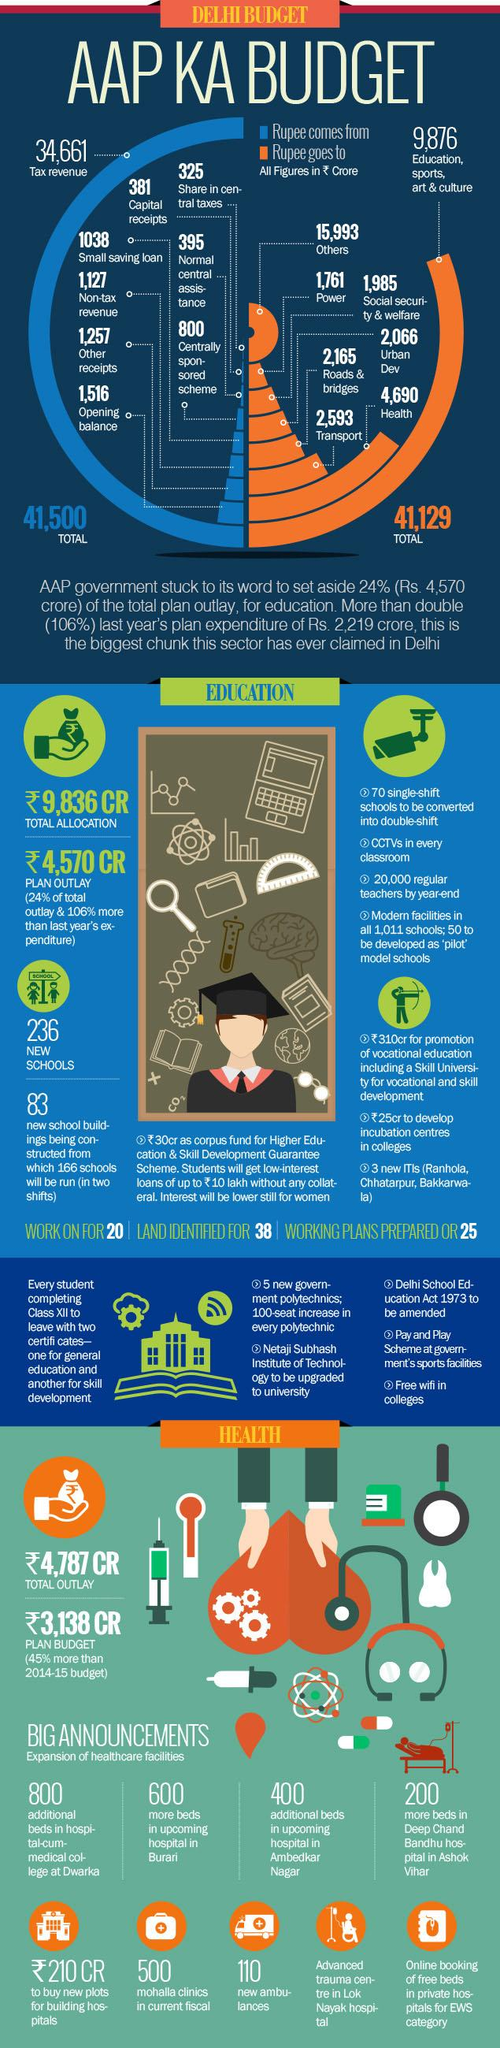Identify some key points in this picture. The expenditure allocation for education in ₹ Crores is 9,836. The allocation of expenditure in education in the current year was increased by 106% compared to the previous year. According to the infographic, the total revenue is 41,500 ₹ crores. According to the infographic, the total expenditure was ₹ 41,129 crores. The expenditure in ₹ crores for health, social security, and welfare put together is 6,675. 